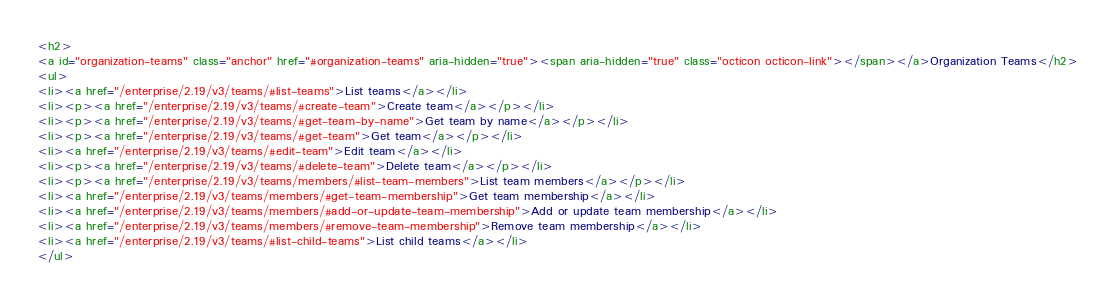Convert code to text. <code><loc_0><loc_0><loc_500><loc_500><_HTML_><h2>
<a id="organization-teams" class="anchor" href="#organization-teams" aria-hidden="true"><span aria-hidden="true" class="octicon octicon-link"></span></a>Organization Teams</h2>
<ul>
<li><a href="/enterprise/2.19/v3/teams/#list-teams">List teams</a></li>
<li><p><a href="/enterprise/2.19/v3/teams/#create-team">Create team</a></p></li>
<li><p><a href="/enterprise/2.19/v3/teams/#get-team-by-name">Get team by name</a></p></li>
<li><p><a href="/enterprise/2.19/v3/teams/#get-team">Get team</a></p></li>
<li><a href="/enterprise/2.19/v3/teams/#edit-team">Edit team</a></li>
<li><p><a href="/enterprise/2.19/v3/teams/#delete-team">Delete team</a></p></li>
<li><p><a href="/enterprise/2.19/v3/teams/members/#list-team-members">List team members</a></p></li>
<li><a href="/enterprise/2.19/v3/teams/members/#get-team-membership">Get team membership</a></li>
<li><a href="/enterprise/2.19/v3/teams/members/#add-or-update-team-membership">Add or update team membership</a></li>
<li><a href="/enterprise/2.19/v3/teams/members/#remove-team-membership">Remove team membership</a></li>
<li><a href="/enterprise/2.19/v3/teams/#list-child-teams">List child teams</a></li>
</ul></code> 